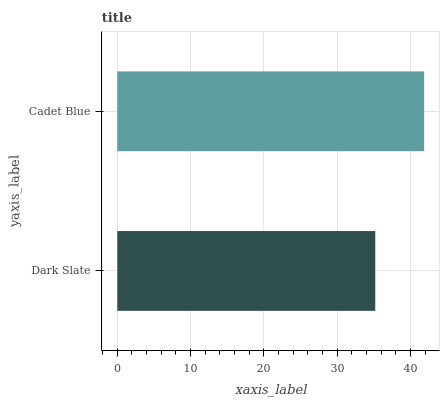Is Dark Slate the minimum?
Answer yes or no. Yes. Is Cadet Blue the maximum?
Answer yes or no. Yes. Is Cadet Blue the minimum?
Answer yes or no. No. Is Cadet Blue greater than Dark Slate?
Answer yes or no. Yes. Is Dark Slate less than Cadet Blue?
Answer yes or no. Yes. Is Dark Slate greater than Cadet Blue?
Answer yes or no. No. Is Cadet Blue less than Dark Slate?
Answer yes or no. No. Is Cadet Blue the high median?
Answer yes or no. Yes. Is Dark Slate the low median?
Answer yes or no. Yes. Is Dark Slate the high median?
Answer yes or no. No. Is Cadet Blue the low median?
Answer yes or no. No. 